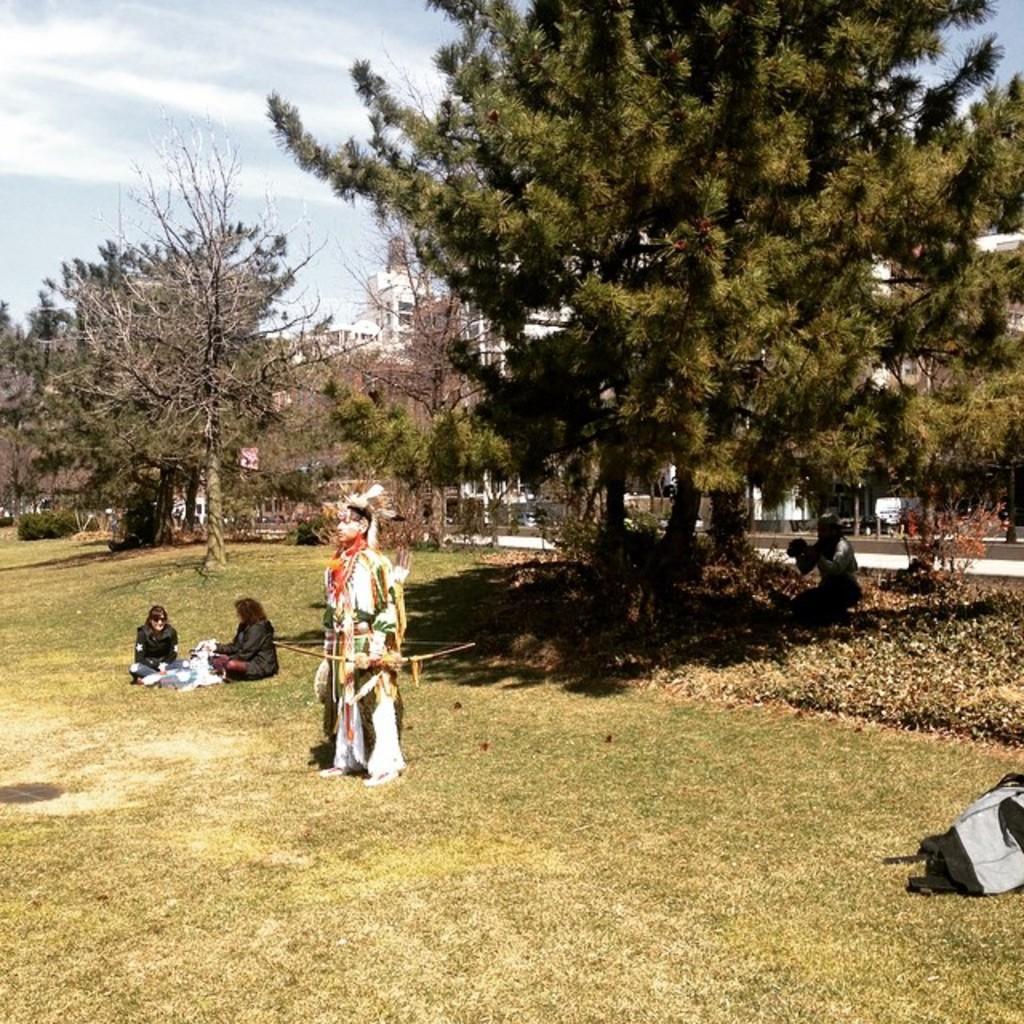Could you give a brief overview of what you see in this image? In this image, we can see people are on the grass. Here we can see plants, trees, bag and person. Background there are few buildings, walkway and sky. 